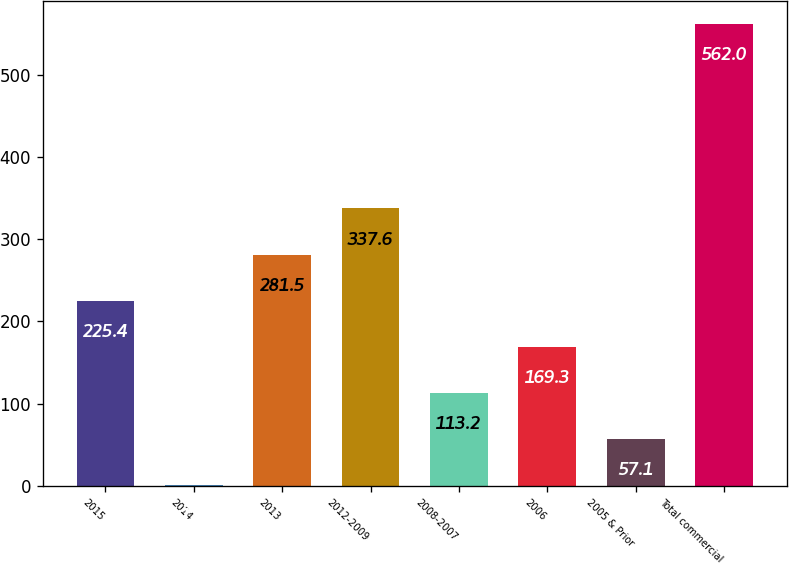Convert chart to OTSL. <chart><loc_0><loc_0><loc_500><loc_500><bar_chart><fcel>2015<fcel>2014<fcel>2013<fcel>2012-2009<fcel>2008-2007<fcel>2006<fcel>2005 & Prior<fcel>Total commercial<nl><fcel>225.4<fcel>1<fcel>281.5<fcel>337.6<fcel>113.2<fcel>169.3<fcel>57.1<fcel>562<nl></chart> 